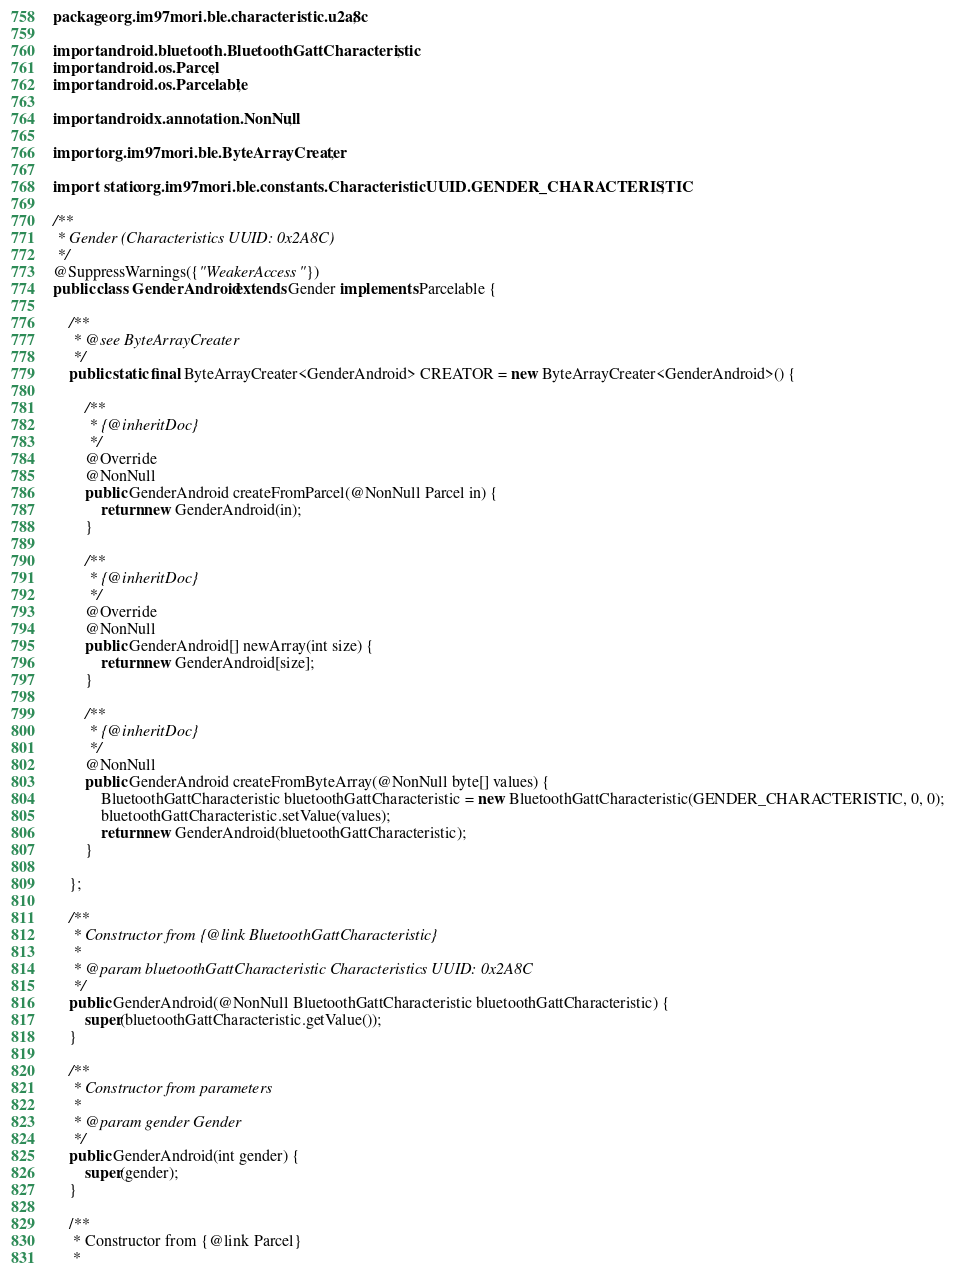<code> <loc_0><loc_0><loc_500><loc_500><_Java_>package org.im97mori.ble.characteristic.u2a8c;

import android.bluetooth.BluetoothGattCharacteristic;
import android.os.Parcel;
import android.os.Parcelable;

import androidx.annotation.NonNull;

import org.im97mori.ble.ByteArrayCreater;

import static org.im97mori.ble.constants.CharacteristicUUID.GENDER_CHARACTERISTIC;

/**
 * Gender (Characteristics UUID: 0x2A8C)
 */
@SuppressWarnings({"WeakerAccess"})
public class GenderAndroid extends Gender implements Parcelable {

    /**
     * @see ByteArrayCreater
     */
    public static final ByteArrayCreater<GenderAndroid> CREATOR = new ByteArrayCreater<GenderAndroid>() {

        /**
         * {@inheritDoc}
         */
        @Override
        @NonNull
        public GenderAndroid createFromParcel(@NonNull Parcel in) {
            return new GenderAndroid(in);
        }

        /**
         * {@inheritDoc}
         */
        @Override
        @NonNull
        public GenderAndroid[] newArray(int size) {
            return new GenderAndroid[size];
        }

        /**
         * {@inheritDoc}
         */
        @NonNull
        public GenderAndroid createFromByteArray(@NonNull byte[] values) {
            BluetoothGattCharacteristic bluetoothGattCharacteristic = new BluetoothGattCharacteristic(GENDER_CHARACTERISTIC, 0, 0);
            bluetoothGattCharacteristic.setValue(values);
            return new GenderAndroid(bluetoothGattCharacteristic);
        }

    };

    /**
     * Constructor from {@link BluetoothGattCharacteristic}
     *
     * @param bluetoothGattCharacteristic Characteristics UUID: 0x2A8C
     */
    public GenderAndroid(@NonNull BluetoothGattCharacteristic bluetoothGattCharacteristic) {
        super(bluetoothGattCharacteristic.getValue());
    }

    /**
     * Constructor from parameters
     *
     * @param gender Gender
     */
    public GenderAndroid(int gender) {
        super(gender);
    }

    /**
     * Constructor from {@link Parcel}
     *</code> 